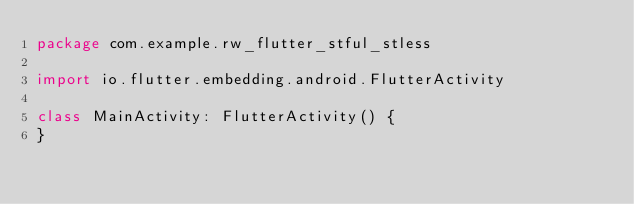<code> <loc_0><loc_0><loc_500><loc_500><_Kotlin_>package com.example.rw_flutter_stful_stless

import io.flutter.embedding.android.FlutterActivity

class MainActivity: FlutterActivity() {
}
</code> 